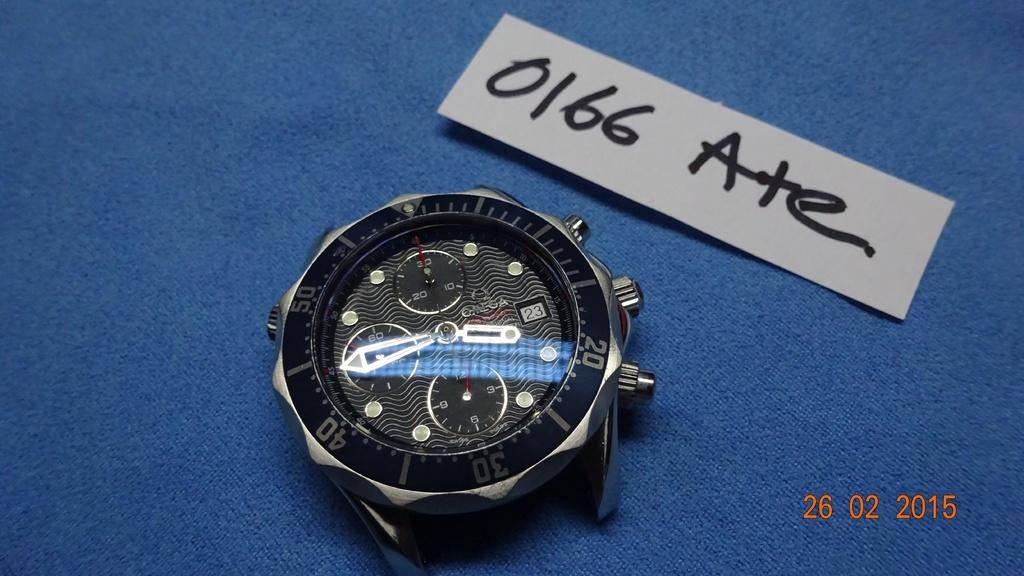<image>
Create a compact narrative representing the image presented. A watch face sits next to paper that says 0166 Ate 